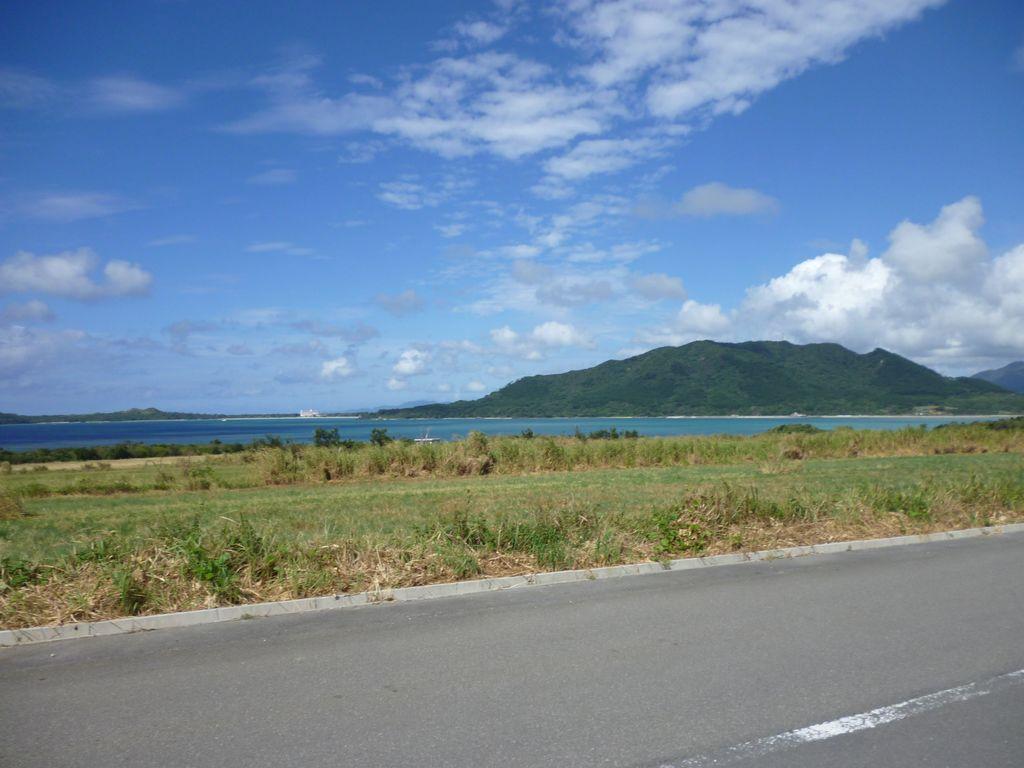Can you describe this image briefly? At the bottom, we see the road. In the middle, we see the grass and the trees, Behind that, we see water and this water might be in the lake. There are trees and the hills in the background. At the top, we see the clouds and the sky, which is blue in color. 